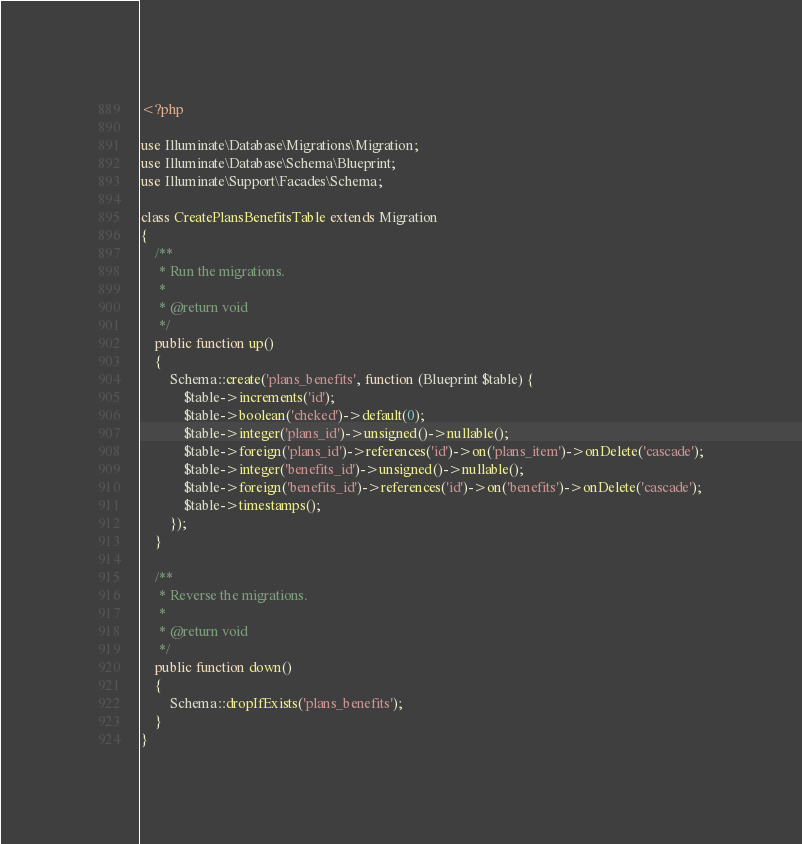Convert code to text. <code><loc_0><loc_0><loc_500><loc_500><_PHP_><?php

use Illuminate\Database\Migrations\Migration;
use Illuminate\Database\Schema\Blueprint;
use Illuminate\Support\Facades\Schema;

class CreatePlansBenefitsTable extends Migration
{
    /**
     * Run the migrations.
     *
     * @return void
     */
    public function up()
    {
        Schema::create('plans_benefits', function (Blueprint $table) {
            $table->increments('id');
            $table->boolean('cheked')->default(0);
            $table->integer('plans_id')->unsigned()->nullable();
            $table->foreign('plans_id')->references('id')->on('plans_item')->onDelete('cascade');
            $table->integer('benefits_id')->unsigned()->nullable();
            $table->foreign('benefits_id')->references('id')->on('benefits')->onDelete('cascade');
            $table->timestamps();
        });
    }

    /**
     * Reverse the migrations.
     *
     * @return void
     */
    public function down()
    {
        Schema::dropIfExists('plans_benefits');
    }
}
</code> 